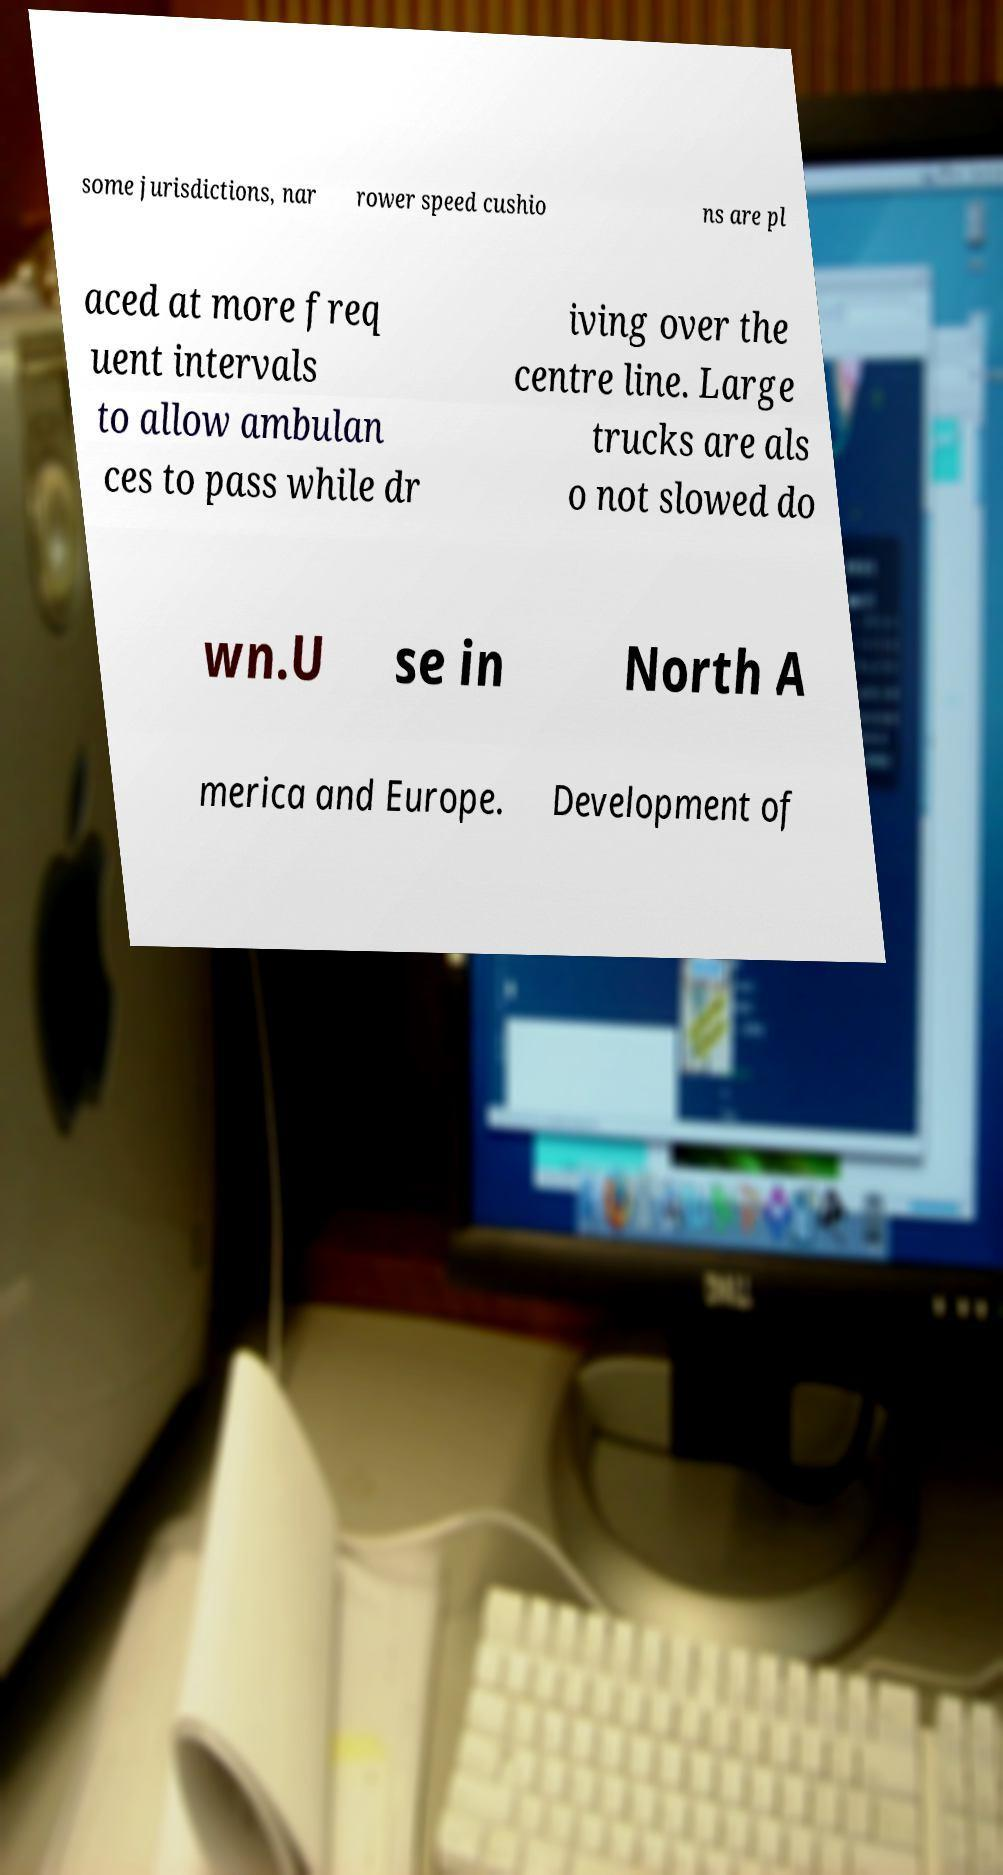Please read and relay the text visible in this image. What does it say? some jurisdictions, nar rower speed cushio ns are pl aced at more freq uent intervals to allow ambulan ces to pass while dr iving over the centre line. Large trucks are als o not slowed do wn.U se in North A merica and Europe. Development of 